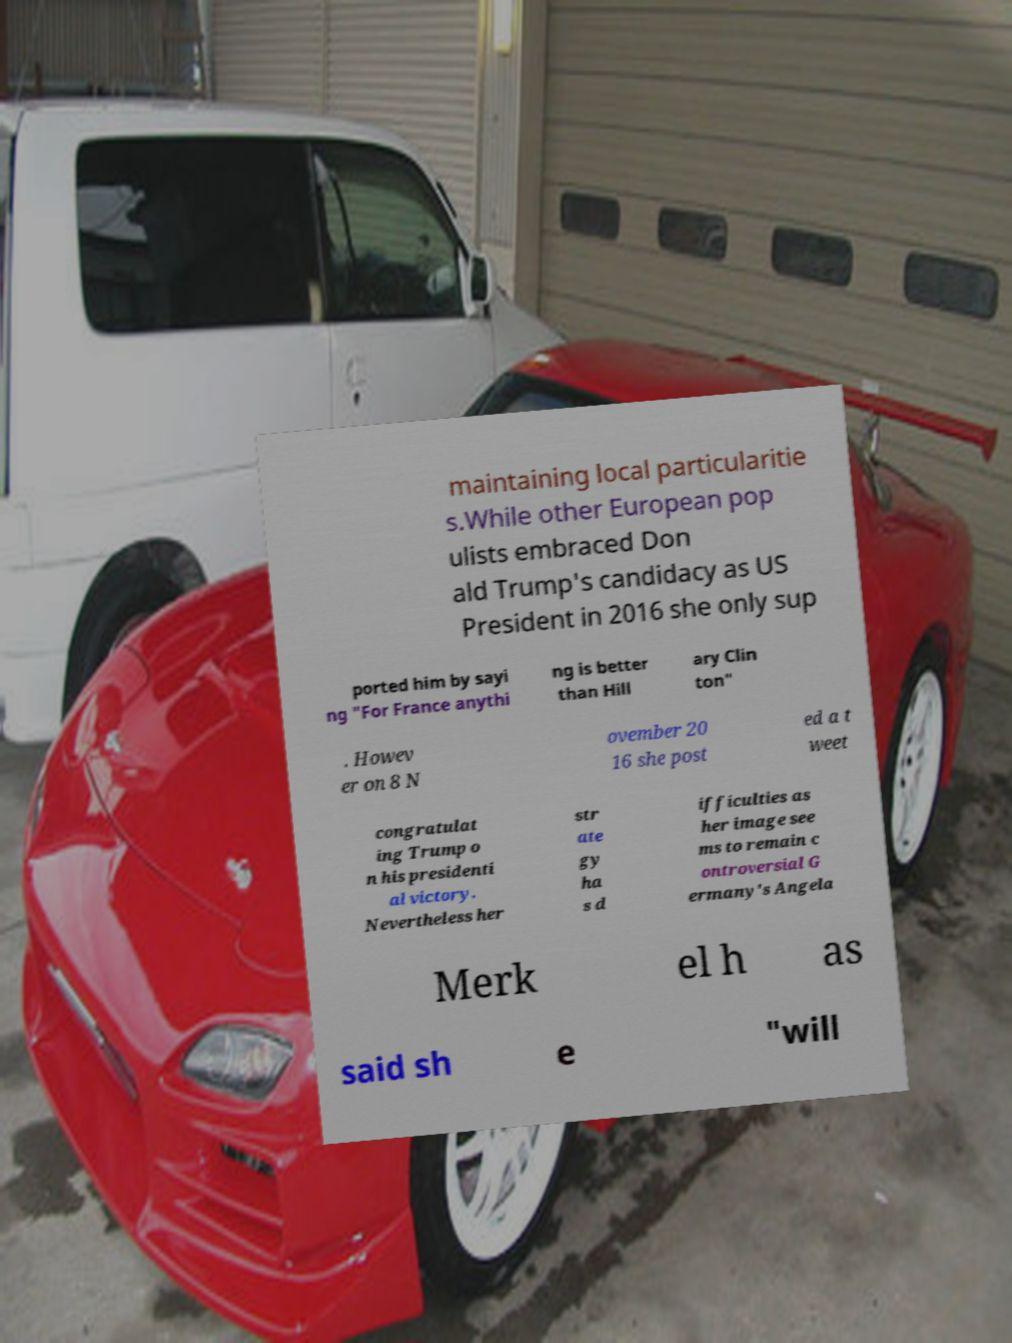Could you extract and type out the text from this image? maintaining local particularitie s.While other European pop ulists embraced Don ald Trump's candidacy as US President in 2016 she only sup ported him by sayi ng "For France anythi ng is better than Hill ary Clin ton" . Howev er on 8 N ovember 20 16 she post ed a t weet congratulat ing Trump o n his presidenti al victory. Nevertheless her str ate gy ha s d ifficulties as her image see ms to remain c ontroversial G ermany's Angela Merk el h as said sh e "will 